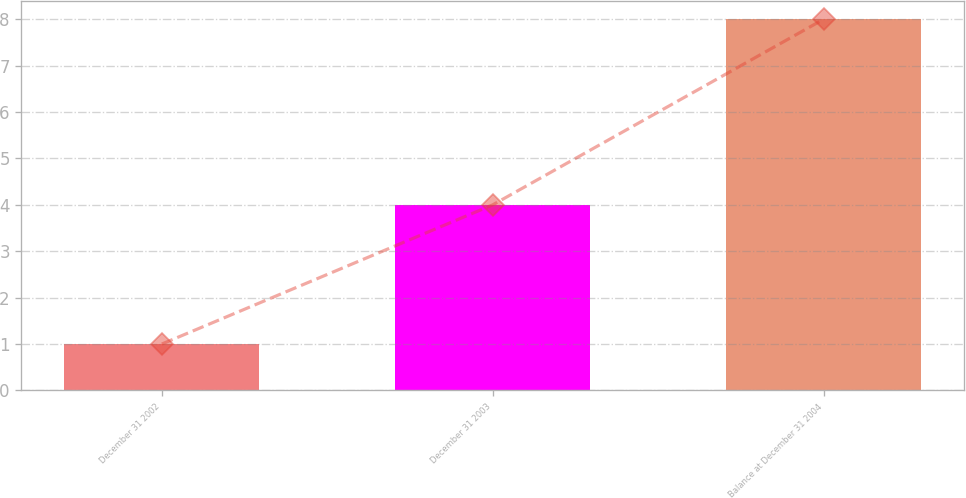<chart> <loc_0><loc_0><loc_500><loc_500><bar_chart><fcel>December 31 2002<fcel>December 31 2003<fcel>Balance at December 31 2004<nl><fcel>1<fcel>4<fcel>8<nl></chart> 